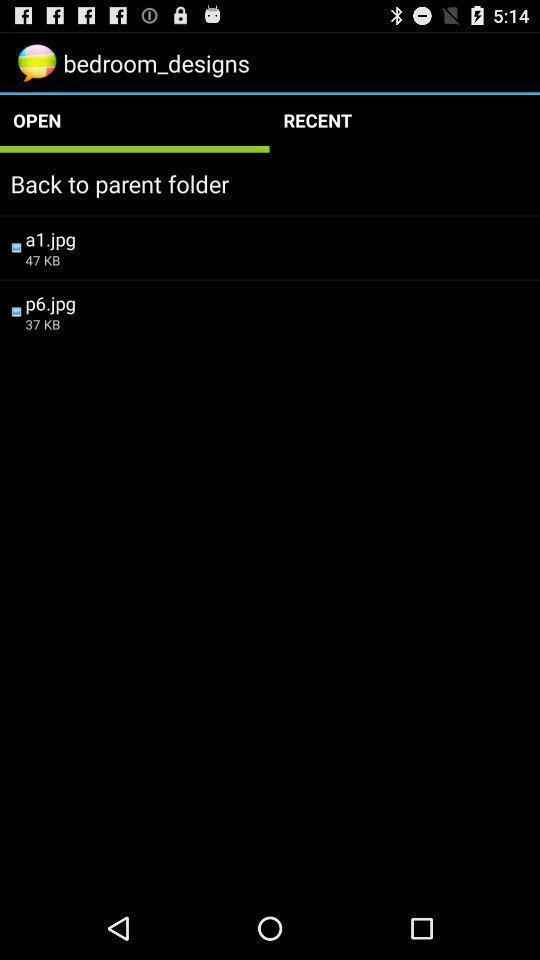What can you discern from this picture? Screen showing back to parent folder. 